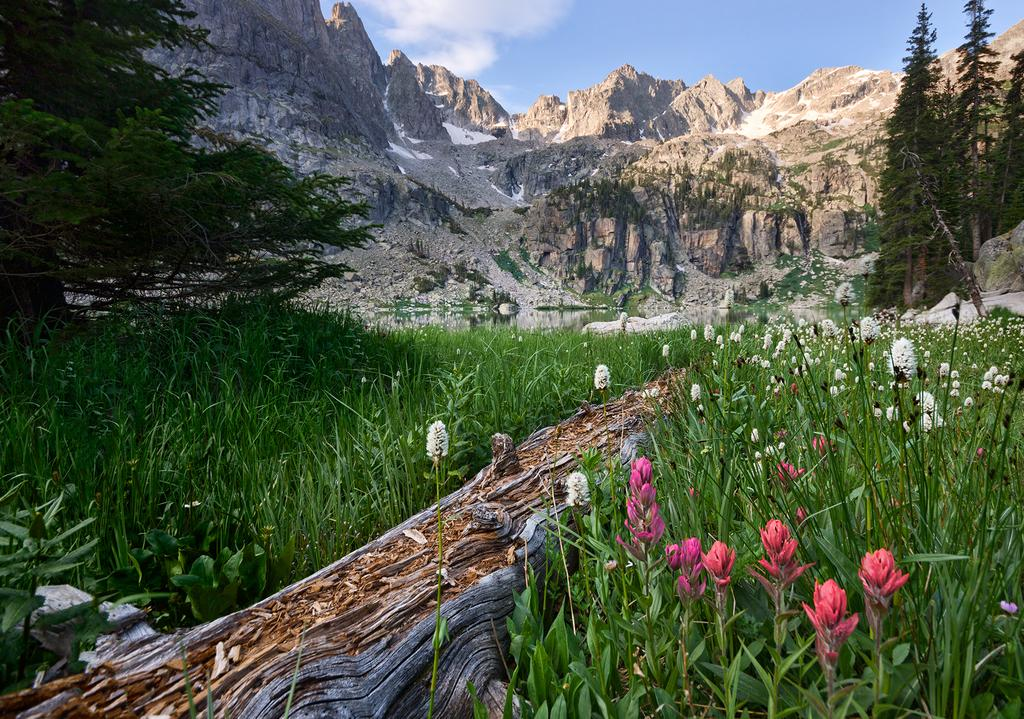What type of vegetation can be seen in the image? There are flowers, plants, grass, and trees in the image. What is the texture of the trees in the image? There is bark in the image in the image, which indicates the texture of the trees. What is visible in the background of the image? The background of the image includes mountains and the sky. How many types of vegetation are present in the image? There are four types of vegetation: flowers, plants, grass, and trees. We ensure that each question is focused on a specific detail about the image that can be answered definitively with the information given. What type of bean is growing on the sister's nerve in the image? There is no mention of a sister, nerve, or bean in the image. The image features flowers, plants, grass, trees, bark, mountains, and the sky. 